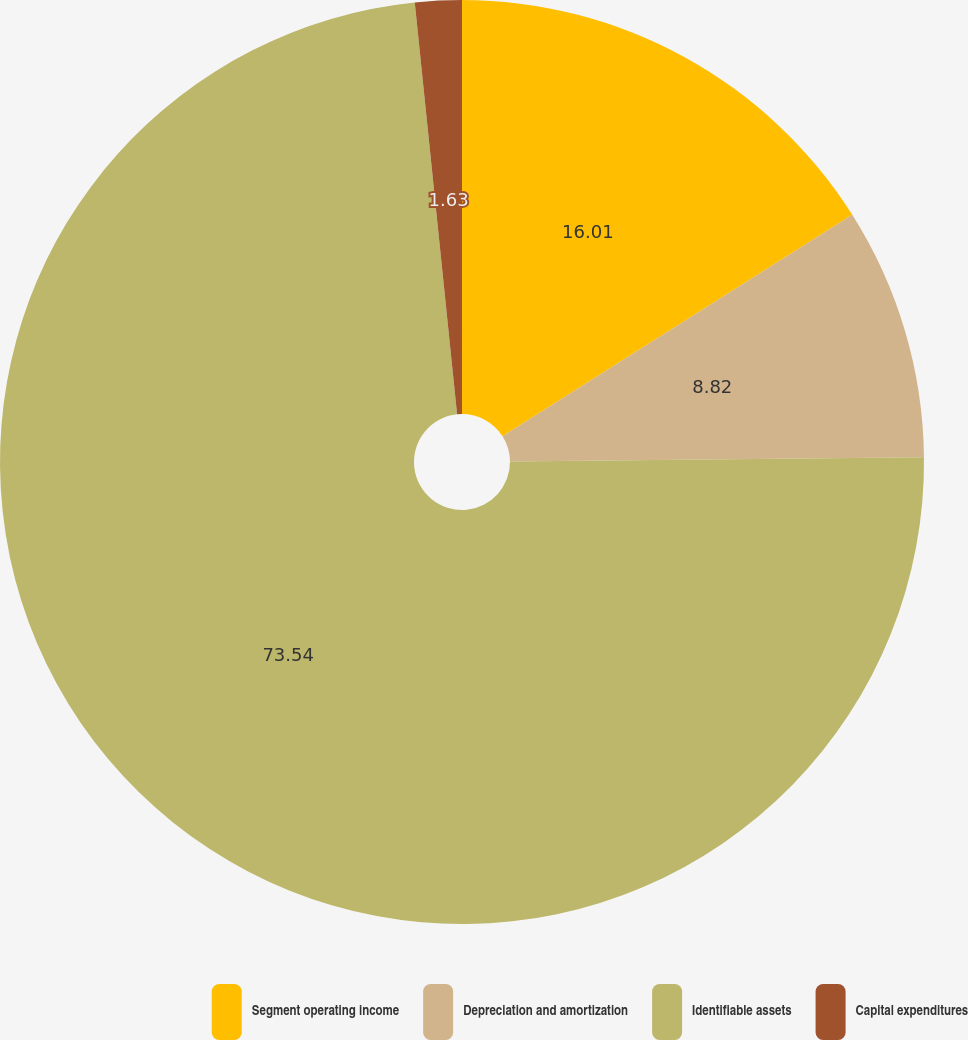Convert chart. <chart><loc_0><loc_0><loc_500><loc_500><pie_chart><fcel>Segment operating income<fcel>Depreciation and amortization<fcel>Identifiable assets<fcel>Capital expenditures<nl><fcel>16.01%<fcel>8.82%<fcel>73.53%<fcel>1.63%<nl></chart> 